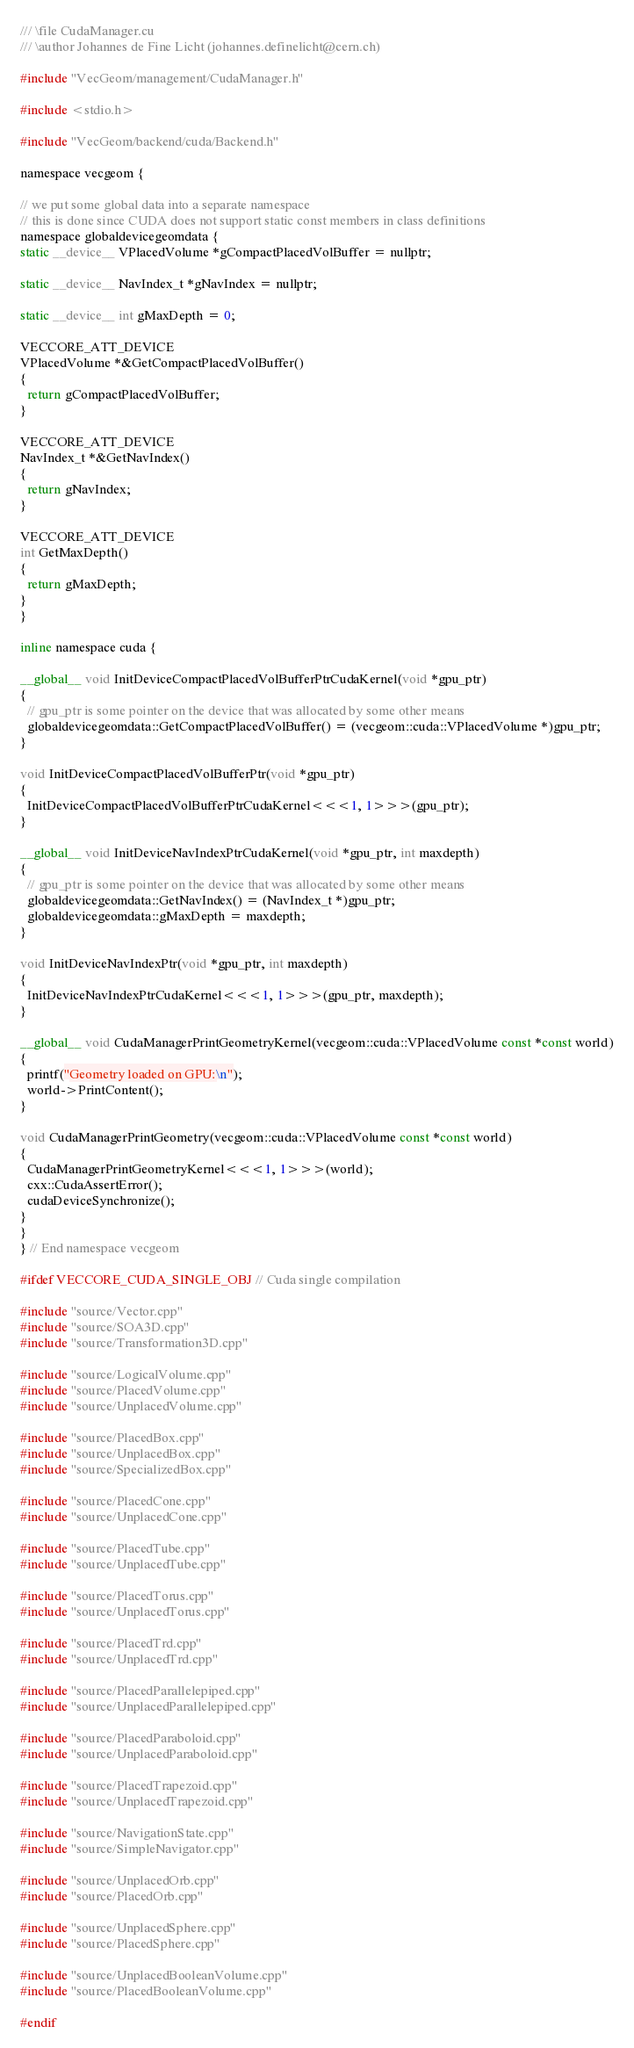<code> <loc_0><loc_0><loc_500><loc_500><_Cuda_>/// \file CudaManager.cu
/// \author Johannes de Fine Licht (johannes.definelicht@cern.ch)

#include "VecGeom/management/CudaManager.h"

#include <stdio.h>

#include "VecGeom/backend/cuda/Backend.h"

namespace vecgeom {

// we put some global data into a separate namespace
// this is done since CUDA does not support static const members in class definitions
namespace globaldevicegeomdata {
static __device__ VPlacedVolume *gCompactPlacedVolBuffer = nullptr;

static __device__ NavIndex_t *gNavIndex = nullptr;

static __device__ int gMaxDepth = 0;

VECCORE_ATT_DEVICE
VPlacedVolume *&GetCompactPlacedVolBuffer()
{
  return gCompactPlacedVolBuffer;
}

VECCORE_ATT_DEVICE
NavIndex_t *&GetNavIndex()
{
  return gNavIndex;
}

VECCORE_ATT_DEVICE
int GetMaxDepth()
{
  return gMaxDepth;
}
}

inline namespace cuda {

__global__ void InitDeviceCompactPlacedVolBufferPtrCudaKernel(void *gpu_ptr)
{
  // gpu_ptr is some pointer on the device that was allocated by some other means
  globaldevicegeomdata::GetCompactPlacedVolBuffer() = (vecgeom::cuda::VPlacedVolume *)gpu_ptr;
}

void InitDeviceCompactPlacedVolBufferPtr(void *gpu_ptr)
{
  InitDeviceCompactPlacedVolBufferPtrCudaKernel<<<1, 1>>>(gpu_ptr);
}

__global__ void InitDeviceNavIndexPtrCudaKernel(void *gpu_ptr, int maxdepth)
{
  // gpu_ptr is some pointer on the device that was allocated by some other means
  globaldevicegeomdata::GetNavIndex() = (NavIndex_t *)gpu_ptr;
  globaldevicegeomdata::gMaxDepth = maxdepth;
}

void InitDeviceNavIndexPtr(void *gpu_ptr, int maxdepth)
{
  InitDeviceNavIndexPtrCudaKernel<<<1, 1>>>(gpu_ptr, maxdepth);
}

__global__ void CudaManagerPrintGeometryKernel(vecgeom::cuda::VPlacedVolume const *const world)
{
  printf("Geometry loaded on GPU:\n");
  world->PrintContent();
}

void CudaManagerPrintGeometry(vecgeom::cuda::VPlacedVolume const *const world)
{
  CudaManagerPrintGeometryKernel<<<1, 1>>>(world);
  cxx::CudaAssertError();
  cudaDeviceSynchronize();
}
}
} // End namespace vecgeom

#ifdef VECCORE_CUDA_SINGLE_OBJ // Cuda single compilation

#include "source/Vector.cpp"
#include "source/SOA3D.cpp"
#include "source/Transformation3D.cpp"

#include "source/LogicalVolume.cpp"
#include "source/PlacedVolume.cpp"
#include "source/UnplacedVolume.cpp"

#include "source/PlacedBox.cpp"
#include "source/UnplacedBox.cpp"
#include "source/SpecializedBox.cpp"

#include "source/PlacedCone.cpp"
#include "source/UnplacedCone.cpp"

#include "source/PlacedTube.cpp"
#include "source/UnplacedTube.cpp"

#include "source/PlacedTorus.cpp"
#include "source/UnplacedTorus.cpp"

#include "source/PlacedTrd.cpp"
#include "source/UnplacedTrd.cpp"

#include "source/PlacedParallelepiped.cpp"
#include "source/UnplacedParallelepiped.cpp"

#include "source/PlacedParaboloid.cpp"
#include "source/UnplacedParaboloid.cpp"

#include "source/PlacedTrapezoid.cpp"
#include "source/UnplacedTrapezoid.cpp"

#include "source/NavigationState.cpp"
#include "source/SimpleNavigator.cpp"

#include "source/UnplacedOrb.cpp"
#include "source/PlacedOrb.cpp"

#include "source/UnplacedSphere.cpp"
#include "source/PlacedSphere.cpp"

#include "source/UnplacedBooleanVolume.cpp"
#include "source/PlacedBooleanVolume.cpp"

#endif
</code> 